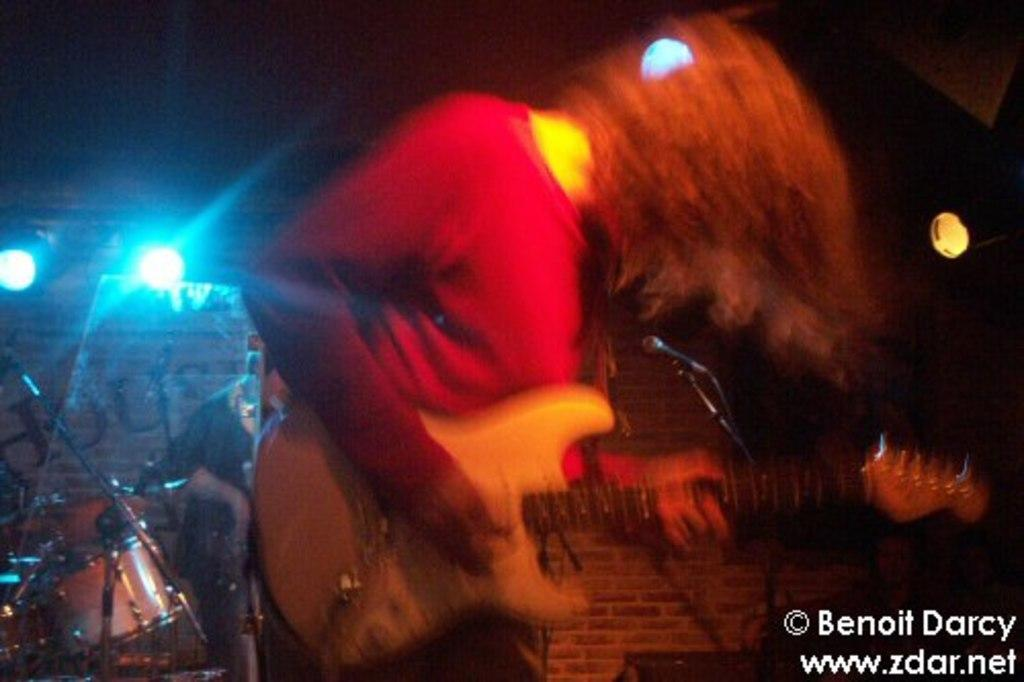Who is present in the image? There are women in the image. What is the woman doing in the image? The woman is standing. What object is the woman holding in her hand? The woman is holding a guitar in her hand. What type of stove can be seen in the background of the image? There is no stove present in the image. What type of stitch is the woman using to play the guitar in the image? The woman is not using a stitch to play the guitar; she is holding it and likely strumming or plucking the strings. 